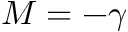Convert formula to latex. <formula><loc_0><loc_0><loc_500><loc_500>M = - \gamma</formula> 